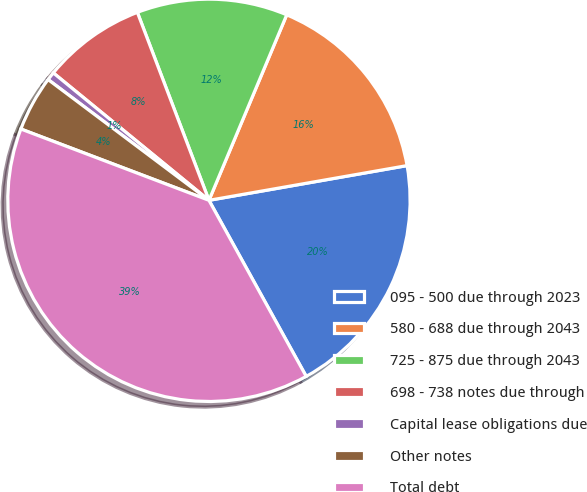<chart> <loc_0><loc_0><loc_500><loc_500><pie_chart><fcel>095 - 500 due through 2023<fcel>580 - 688 due through 2043<fcel>725 - 875 due through 2043<fcel>698 - 738 notes due through<fcel>Capital lease obligations due<fcel>Other notes<fcel>Total debt<nl><fcel>19.73%<fcel>15.92%<fcel>12.11%<fcel>8.29%<fcel>0.67%<fcel>4.48%<fcel>38.8%<nl></chart> 